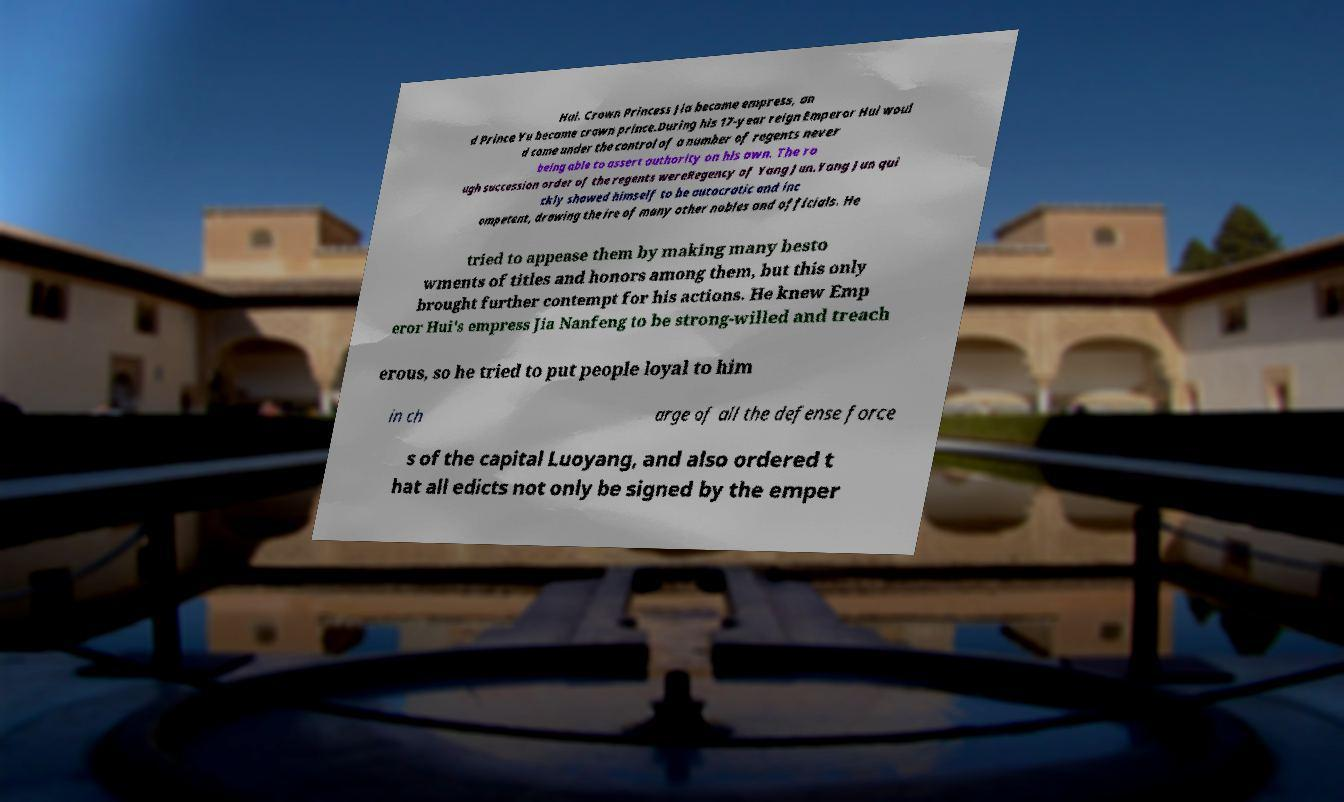I need the written content from this picture converted into text. Can you do that? Hui. Crown Princess Jia became empress, an d Prince Yu became crown prince.During his 17-year reign Emperor Hui woul d come under the control of a number of regents never being able to assert authority on his own. The ro ugh succession order of the regents wereRegency of Yang Jun.Yang Jun qui ckly showed himself to be autocratic and inc ompetent, drawing the ire of many other nobles and officials. He tried to appease them by making many besto wments of titles and honors among them, but this only brought further contempt for his actions. He knew Emp eror Hui's empress Jia Nanfeng to be strong-willed and treach erous, so he tried to put people loyal to him in ch arge of all the defense force s of the capital Luoyang, and also ordered t hat all edicts not only be signed by the emper 